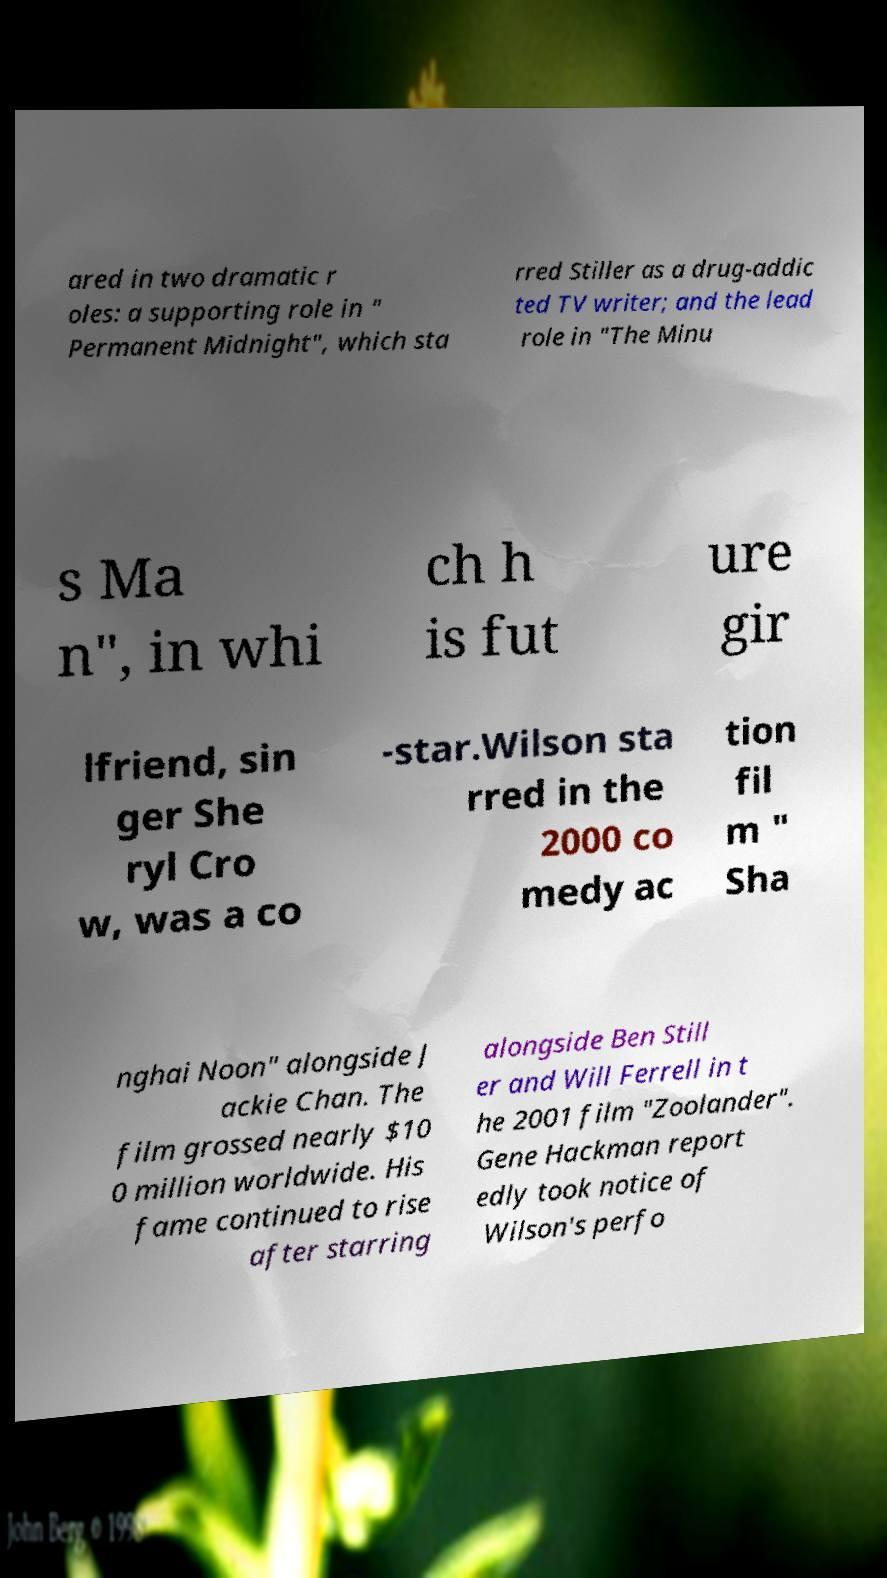For documentation purposes, I need the text within this image transcribed. Could you provide that? ared in two dramatic r oles: a supporting role in " Permanent Midnight", which sta rred Stiller as a drug-addic ted TV writer; and the lead role in "The Minu s Ma n", in whi ch h is fut ure gir lfriend, sin ger She ryl Cro w, was a co -star.Wilson sta rred in the 2000 co medy ac tion fil m " Sha nghai Noon" alongside J ackie Chan. The film grossed nearly $10 0 million worldwide. His fame continued to rise after starring alongside Ben Still er and Will Ferrell in t he 2001 film "Zoolander". Gene Hackman report edly took notice of Wilson's perfo 